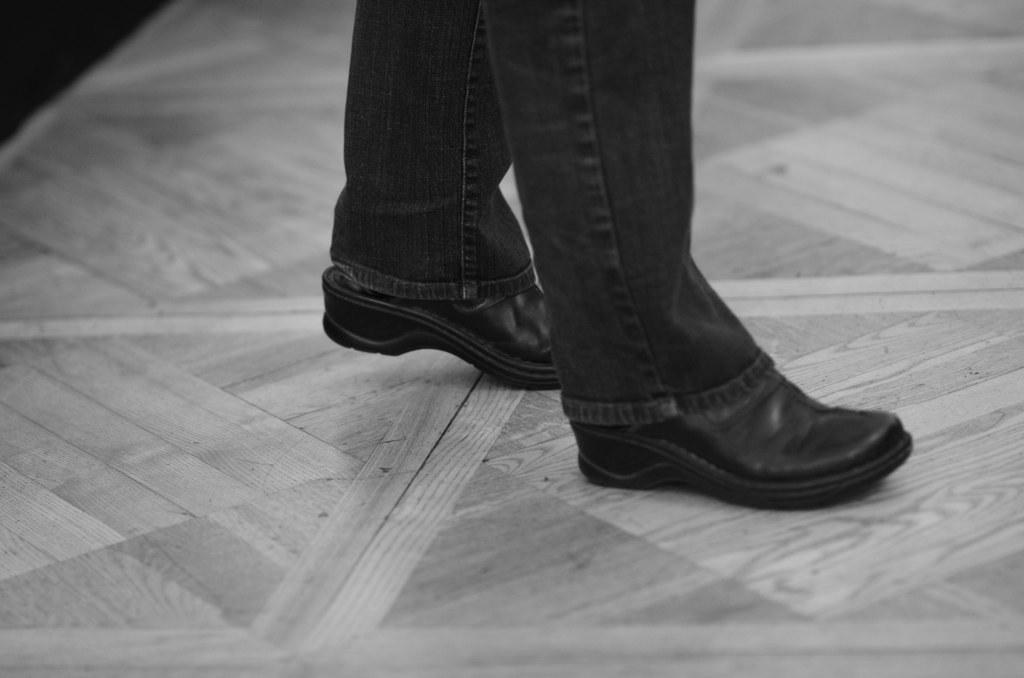What is the main subject of the image? There is a person in the image. What type of pants is the person wearing? The person is wearing jeans pants. What type of shoes is the person wearing? The person is wearing black shoes. What can be seen beneath the person in the image? There is a floor visible in the image. What material is the floor made of? The floor appears to be made of wood. What type of silk fabric is draped over the person's head in the image? There is no silk fabric present in the image. What idea does the person have while standing on the wooden floor? The image does not provide any information about the person's thoughts or ideas. 